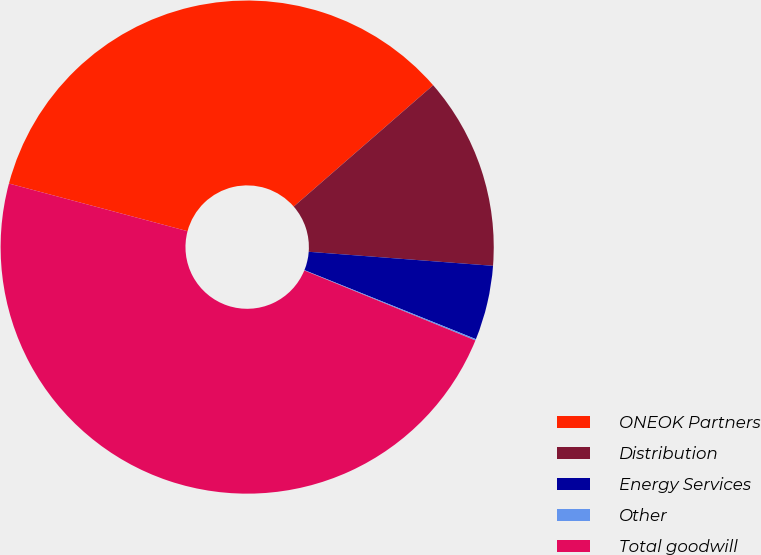<chart> <loc_0><loc_0><loc_500><loc_500><pie_chart><fcel>ONEOK Partners<fcel>Distribution<fcel>Energy Services<fcel>Other<fcel>Total goodwill<nl><fcel>34.45%<fcel>12.61%<fcel>4.88%<fcel>0.09%<fcel>47.97%<nl></chart> 